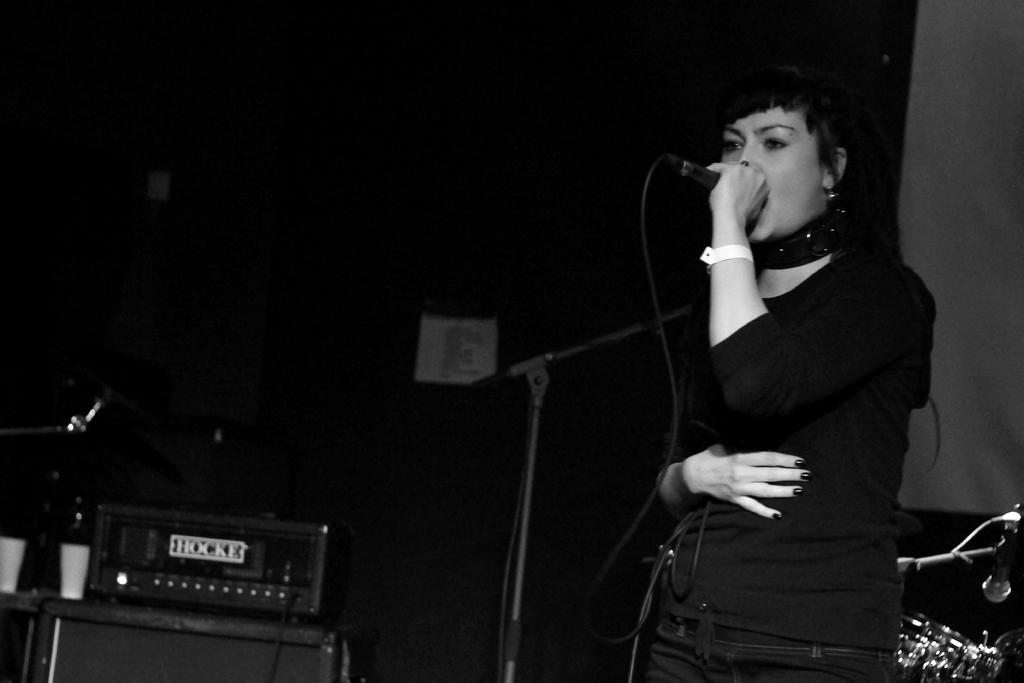Who is the main subject in the image? There is a woman in the image. What is the woman doing in the image? The woman is singing in the image. What tool is the woman using while singing? The woman is using a microphone in the image. What else can be seen in the image besides the woman? There are musical instruments in the image. What type of mint is the woman chewing while singing in the image? There is no mint present in the image, and the woman is not chewing anything while singing. 